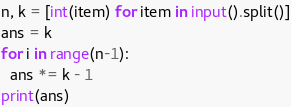Convert code to text. <code><loc_0><loc_0><loc_500><loc_500><_Python_>n, k = [int(item) for item in input().split()]
ans = k
for i in range(n-1):
  ans *= k - 1
print(ans)</code> 